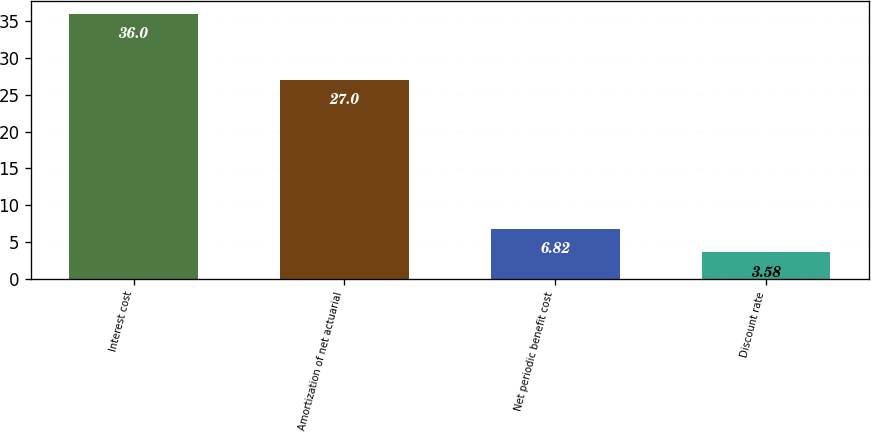Convert chart. <chart><loc_0><loc_0><loc_500><loc_500><bar_chart><fcel>Interest cost<fcel>Amortization of net actuarial<fcel>Net periodic benefit cost<fcel>Discount rate<nl><fcel>36<fcel>27<fcel>6.82<fcel>3.58<nl></chart> 